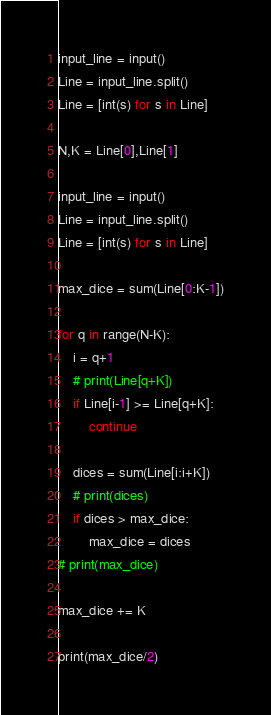Convert code to text. <code><loc_0><loc_0><loc_500><loc_500><_Python_>input_line = input()
Line = input_line.split()
Line = [int(s) for s in Line]

N,K = Line[0],Line[1]

input_line = input()
Line = input_line.split()
Line = [int(s) for s in Line]

max_dice = sum(Line[0:K-1])

for q in range(N-K):
    i = q+1
    # print(Line[q+K])
    if Line[i-1] >= Line[q+K]:
        continue
    
    dices = sum(Line[i:i+K])
    # print(dices)
    if dices > max_dice:
        max_dice = dices
# print(max_dice)

max_dice += K

print(max_dice/2)</code> 